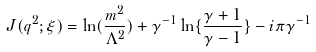Convert formula to latex. <formula><loc_0><loc_0><loc_500><loc_500>J ( q ^ { 2 } ; \xi ) = \ln ( \frac { m ^ { 2 } } { \Lambda ^ { 2 } } ) + \gamma ^ { - 1 } \ln \{ \frac { \gamma + 1 } { \gamma - 1 } \} - i \pi \gamma ^ { - 1 }</formula> 